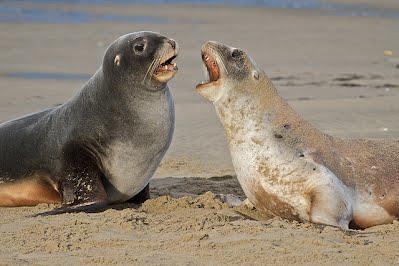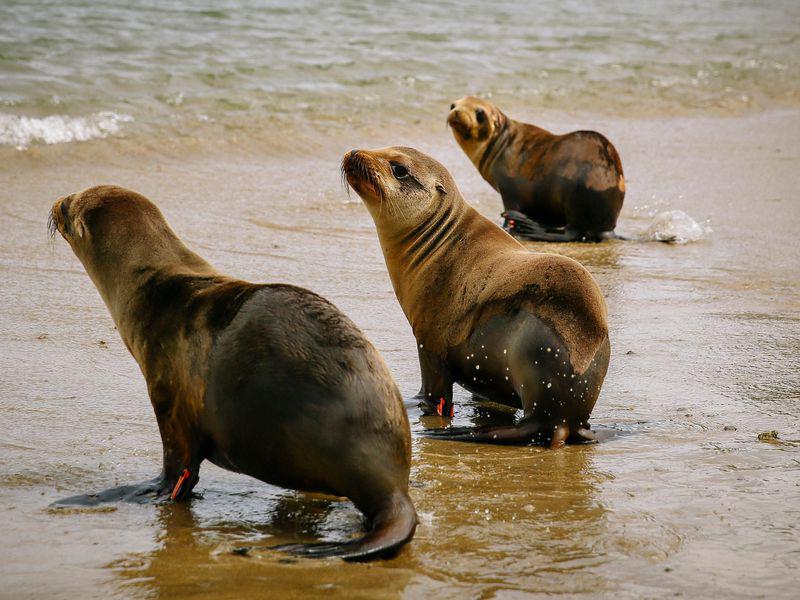The first image is the image on the left, the second image is the image on the right. Evaluate the accuracy of this statement regarding the images: "There are exactly three animals in the image on the right.". Is it true? Answer yes or no. Yes. 